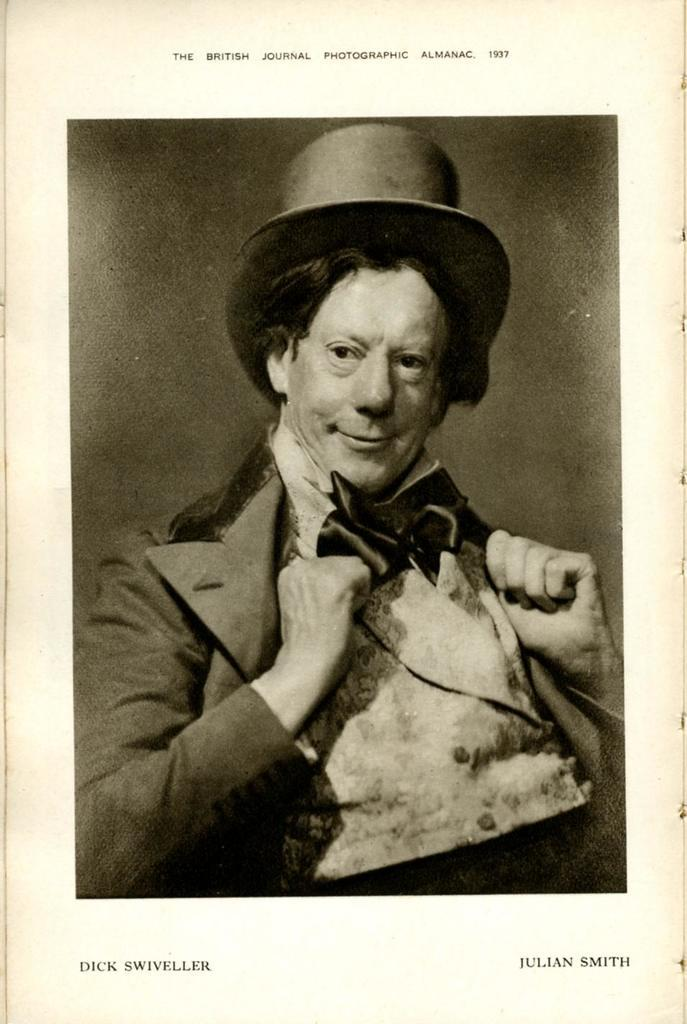What type of document is shown in the image? The image is of a page from a book. What can be seen in the picture on the page? There is a picture of a person on the page. What else is present on the page besides the picture? There is text on the page. What type of appliance is visible in the image? There is no appliance present in the image; it is a page from a book with a picture of a person and text. Can you see a baby playing in the ocean in the image? There is no baby or ocean present in the image; it is a page from a book with a picture of a person and text. 